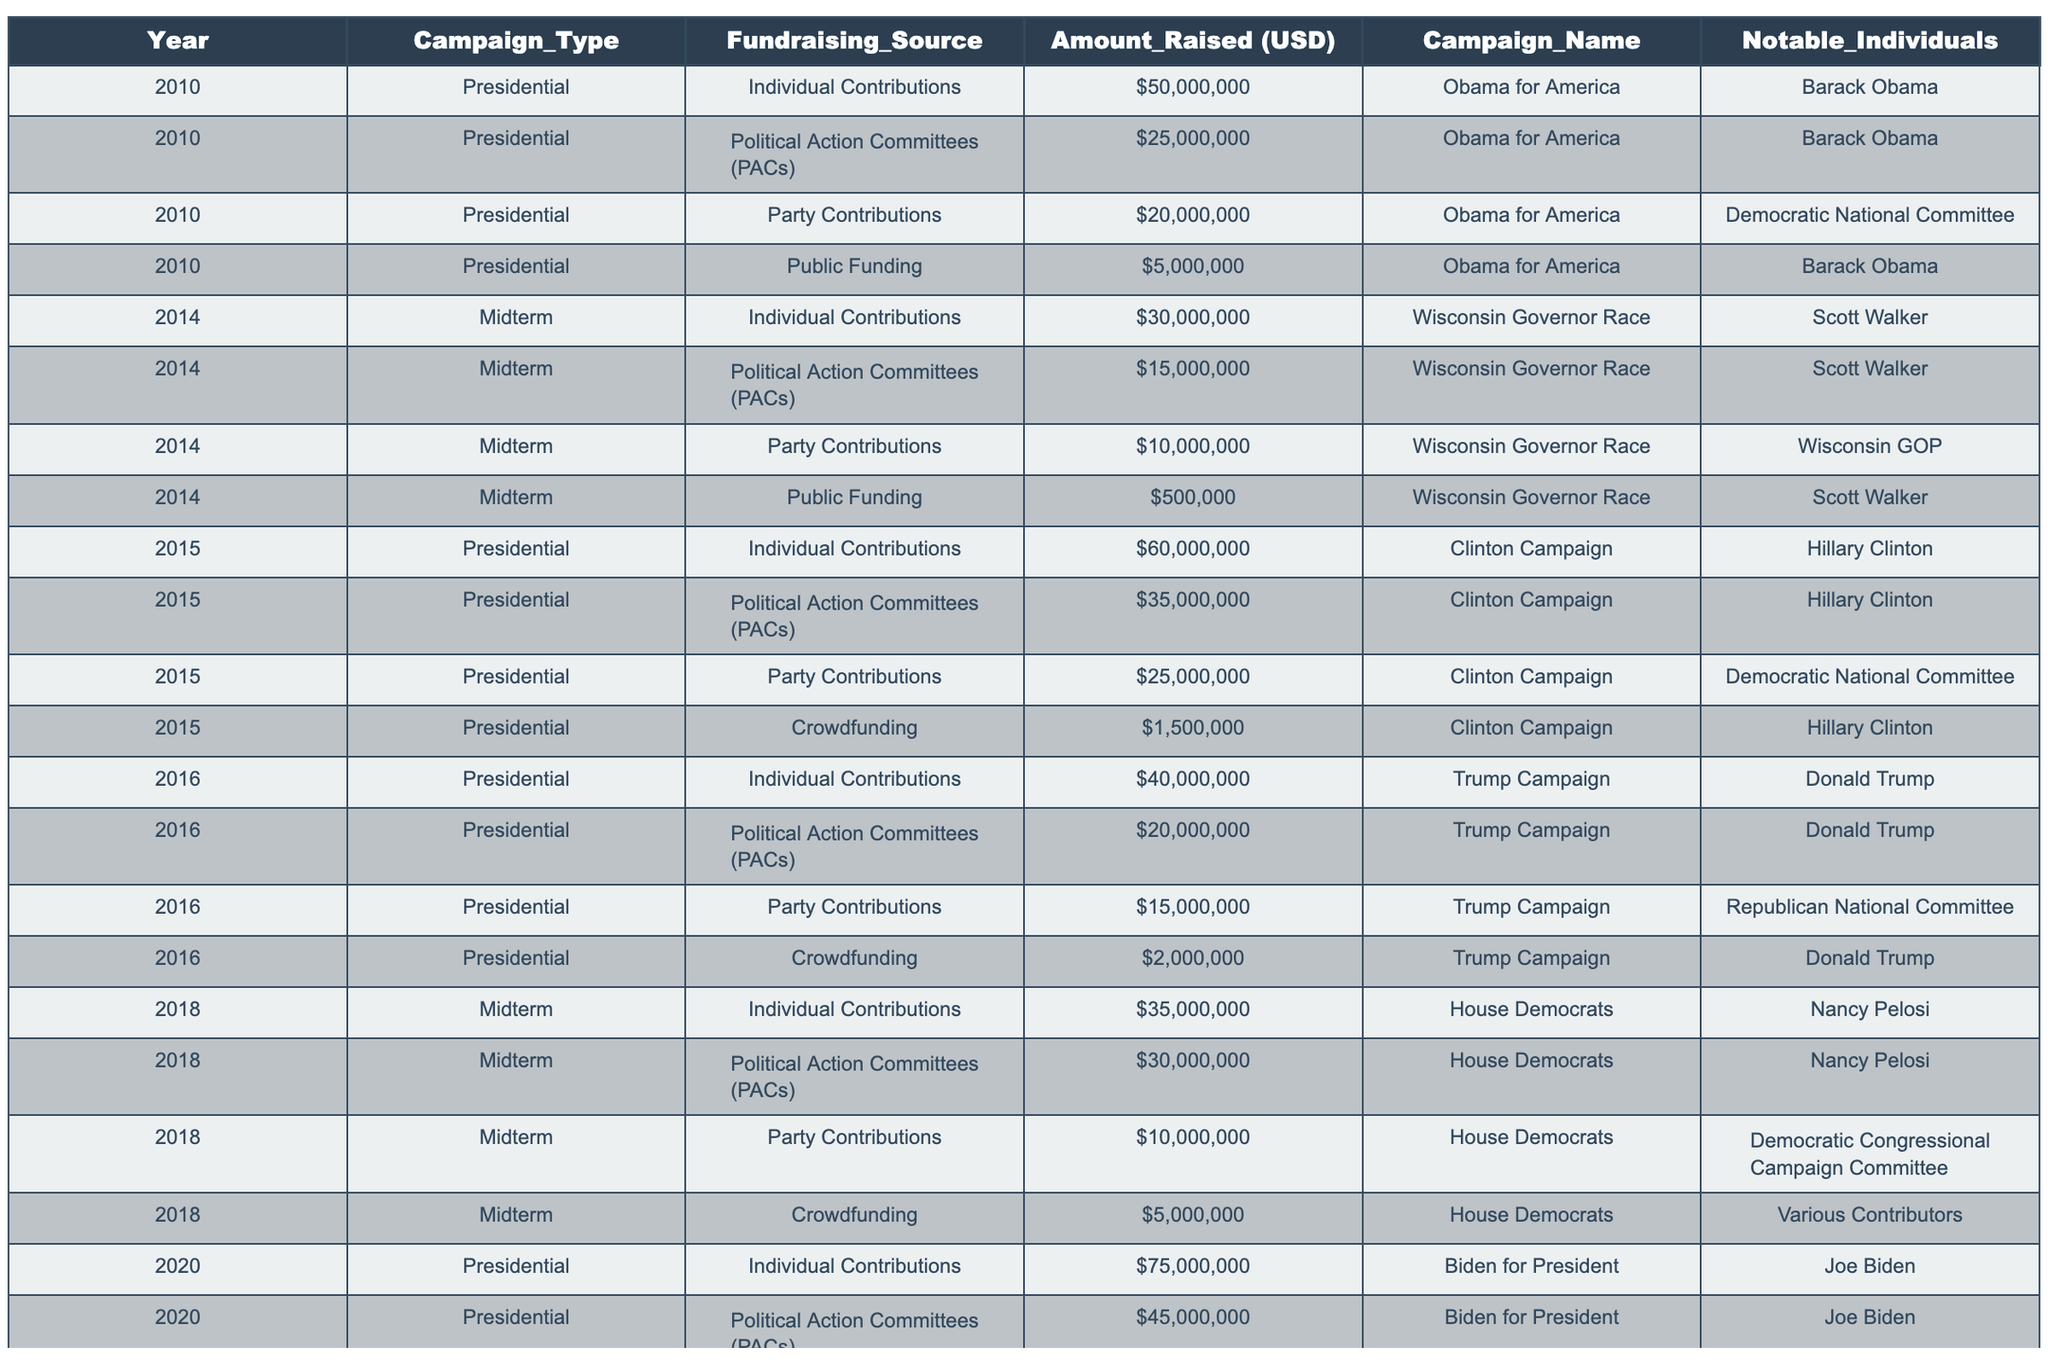What was the total amount raised by individual contributions in the 2020 presidential campaign? Looking at the table, the amount raised by individual contributions for the Biden for President campaign in 2020 is $75,000,000.
Answer: $75,000,000 Which fundraising source contributed the least amount in the 2014 midterm campaign? In the 2014 midterm campaign, the least amount raised was from Public Funding for the Wisconsin Governor Race, which is $500,000.
Answer: $500,000 How much more did PACs raise compared to crowdfunding in the 2015 presidential campaign? In the 2015 presidential campaign, PACs raised $35,000,000 and crowdfunding raised $1,500,000. The difference is $35,000,000 - $1,500,000 = $33,500,000.
Answer: $33,500,000 Did crowdfunding raise more in the 2020 presidential campaign than in the 2018 midterm campaign? In the 2020 presidential campaign, crowdfunding raised $8,000,000, while in the 2018 midterm campaign, crowdfunding raised $5,000,000. Since $8,000,000 is greater than $5,000,000, the statement is true.
Answer: Yes What was the average amount raised from party contributions in the presidential campaigns from 2010 to 2020? The table shows the following amounts for party contributions in presidential campaigns: $20,000,000 (2010), $25,000,000 (2015), $15,000,000 (2016), $30,000,000 (2020). The total is $20,000,000 + $25,000,000 + $15,000,000 + $30,000,000 = $90,000,000. There are 4 data points, so the average is $90,000,000 / 4 = $22,500,000.
Answer: $22,500,000 Which campaign had the highest total amount raised from all sources in the 2018 midterms? For the House Democrats in 2018, the total amounts raised were: Individual Contributions $35,000,000, PACs $30,000,000, Party Contributions $10,000,000, and Crowdfunding $5,000,000. Total = $35,000,000 + $30,000,000 + $10,000,000 + $5,000,000 = $80,000,000, which is the highest for that year.
Answer: $80,000,000 How has the contribution of crowdfunding changed from 2015 to 2020 in presidential campaigns? In the 2015 presidential campaign, crowdfunding raised $1,500,000, and in the 2020 presidential campaign, it raised $8,000,000. The increase is $8,000,000 - $1,500,000 = $6,500,000, showing a significant growth in crowdfunding contributions over the five-year period.
Answer: Increased by $6,500,000 What percentage of the total amount raised by Biden for President in 2020 came from crowdfunding? The total amount raised by Biden in 2020 is $75,000,000 (Individual) + $45,000,000 (PACs) + $30,000,000 (Party) + $8,000,000 (Crowdfunding) = $158,000,000. The amount from crowdfunding is $8,000,000. The percentage is ($8,000,000 / $158,000,000) * 100 ≈ 5.06%.
Answer: Approximately 5.06% Which political campaign notably relied heavily on PAC contributions in the year 2018? The House Democrats' midterm campaign in 2018 raised $30,000,000 from PAC contributions, which is the highest reported for that year among midterm campaigns.
Answer: House Democrats' campaign 